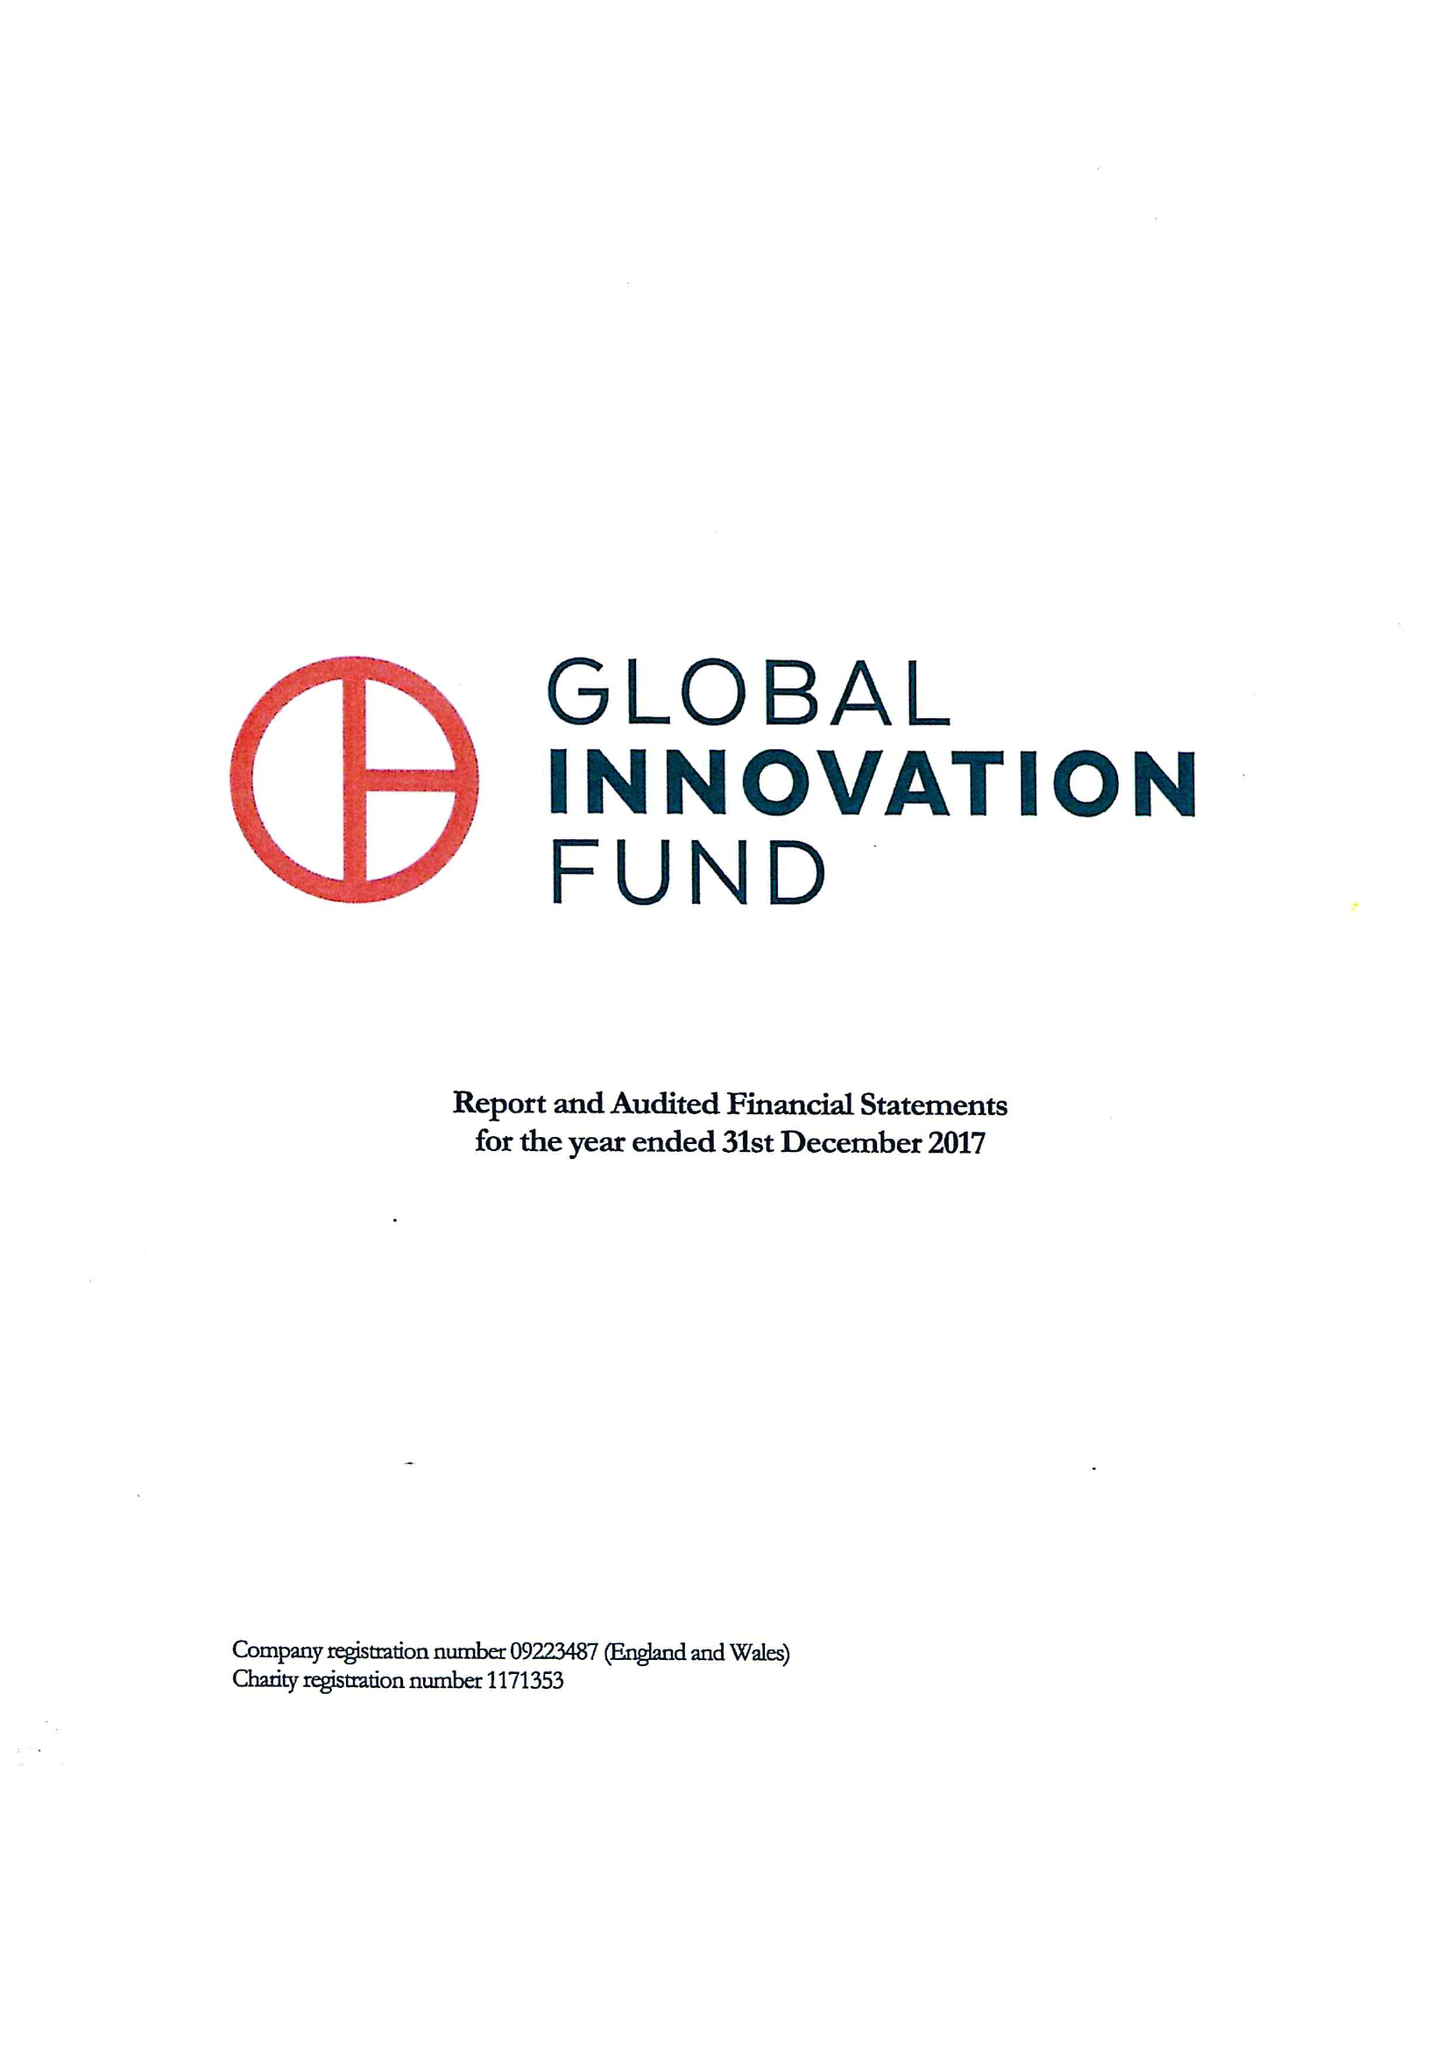What is the value for the report_date?
Answer the question using a single word or phrase. 2017-12-31 